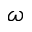<formula> <loc_0><loc_0><loc_500><loc_500>\omega</formula> 